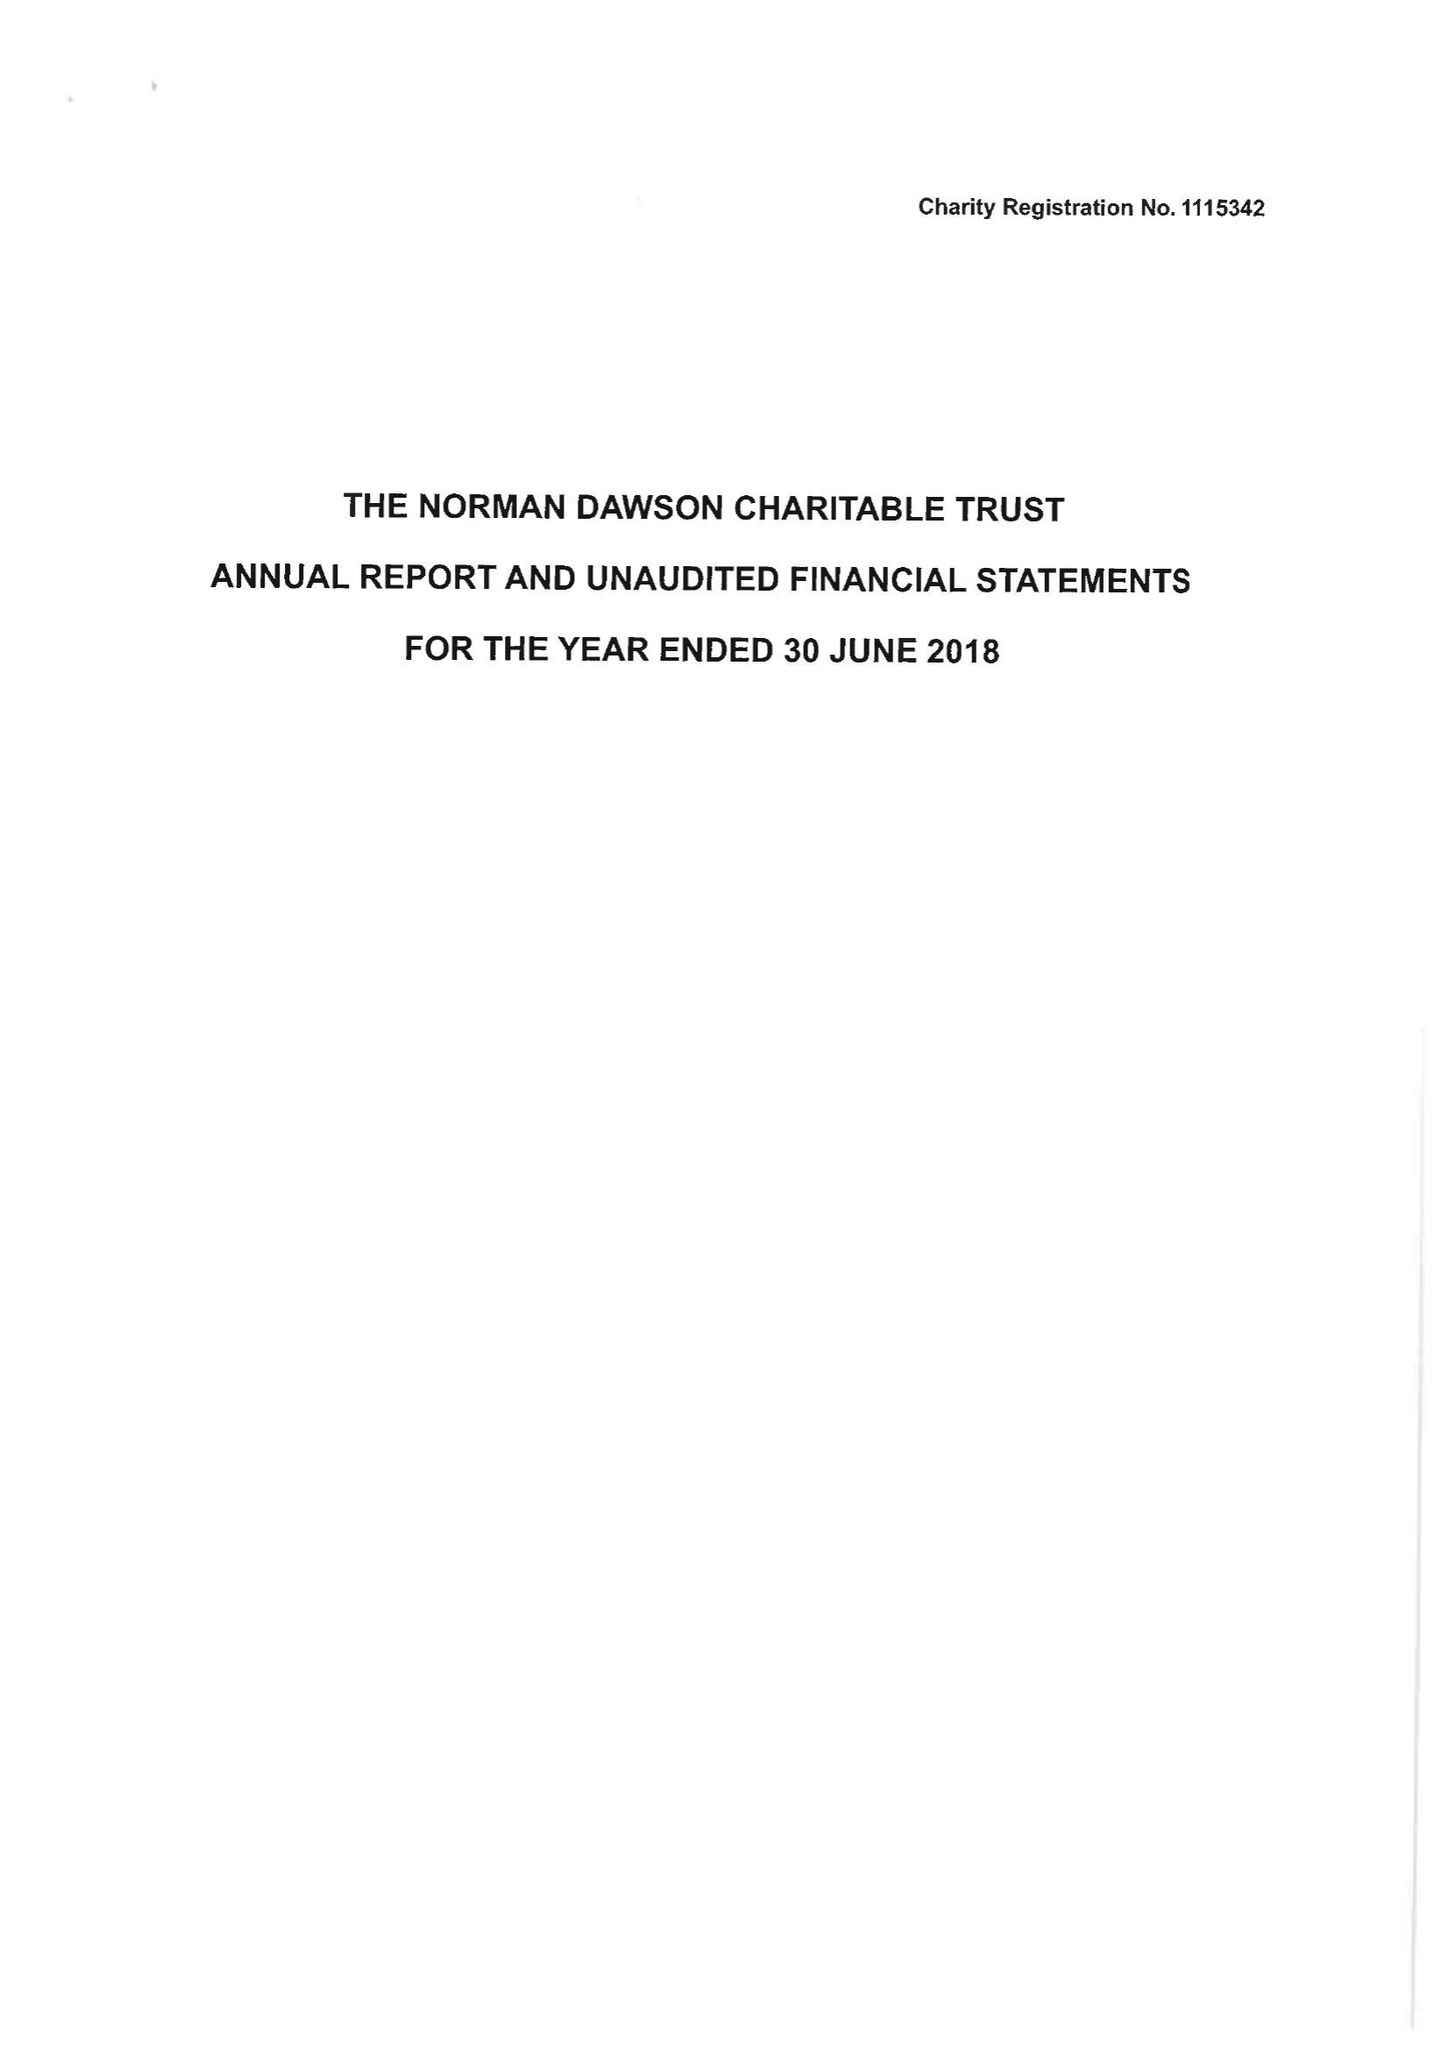What is the value for the income_annually_in_british_pounds?
Answer the question using a single word or phrase. 46177.00 